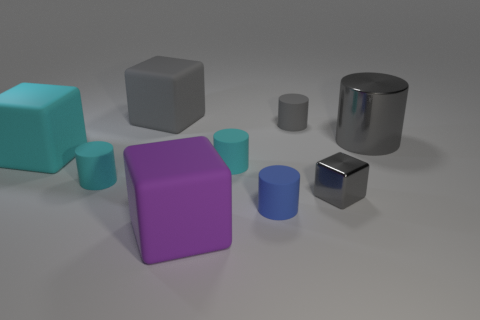How many other things are the same color as the tiny cube?
Offer a very short reply. 3. Are there any other things that have the same shape as the big cyan object?
Make the answer very short. Yes. There is a tiny matte cylinder to the left of the large purple cube; is it the same color as the metallic block?
Give a very brief answer. No. There is a cyan rubber thing that is the same shape as the purple matte thing; what is its size?
Your response must be concise. Large. How many gray things have the same material as the small blue cylinder?
Provide a succinct answer. 2. There is a big thing that is behind the tiny thing that is behind the big cylinder; are there any small cylinders right of it?
Provide a succinct answer. Yes. There is a small gray matte thing; what shape is it?
Offer a terse response. Cylinder. Is the small object to the left of the purple rubber thing made of the same material as the large thing that is on the right side of the purple block?
Your answer should be compact. No. How many shiny blocks are the same color as the metal cylinder?
Your response must be concise. 1. What is the shape of the object that is on the right side of the gray rubber cylinder and on the left side of the large gray shiny cylinder?
Your answer should be compact. Cube. 